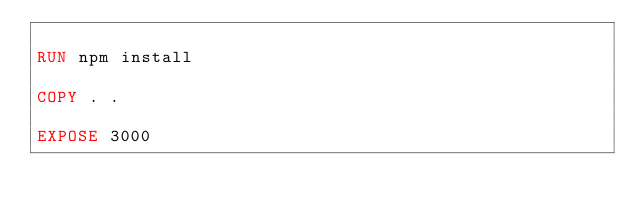<code> <loc_0><loc_0><loc_500><loc_500><_Dockerfile_>
RUN npm install

COPY . .

EXPOSE 3000</code> 